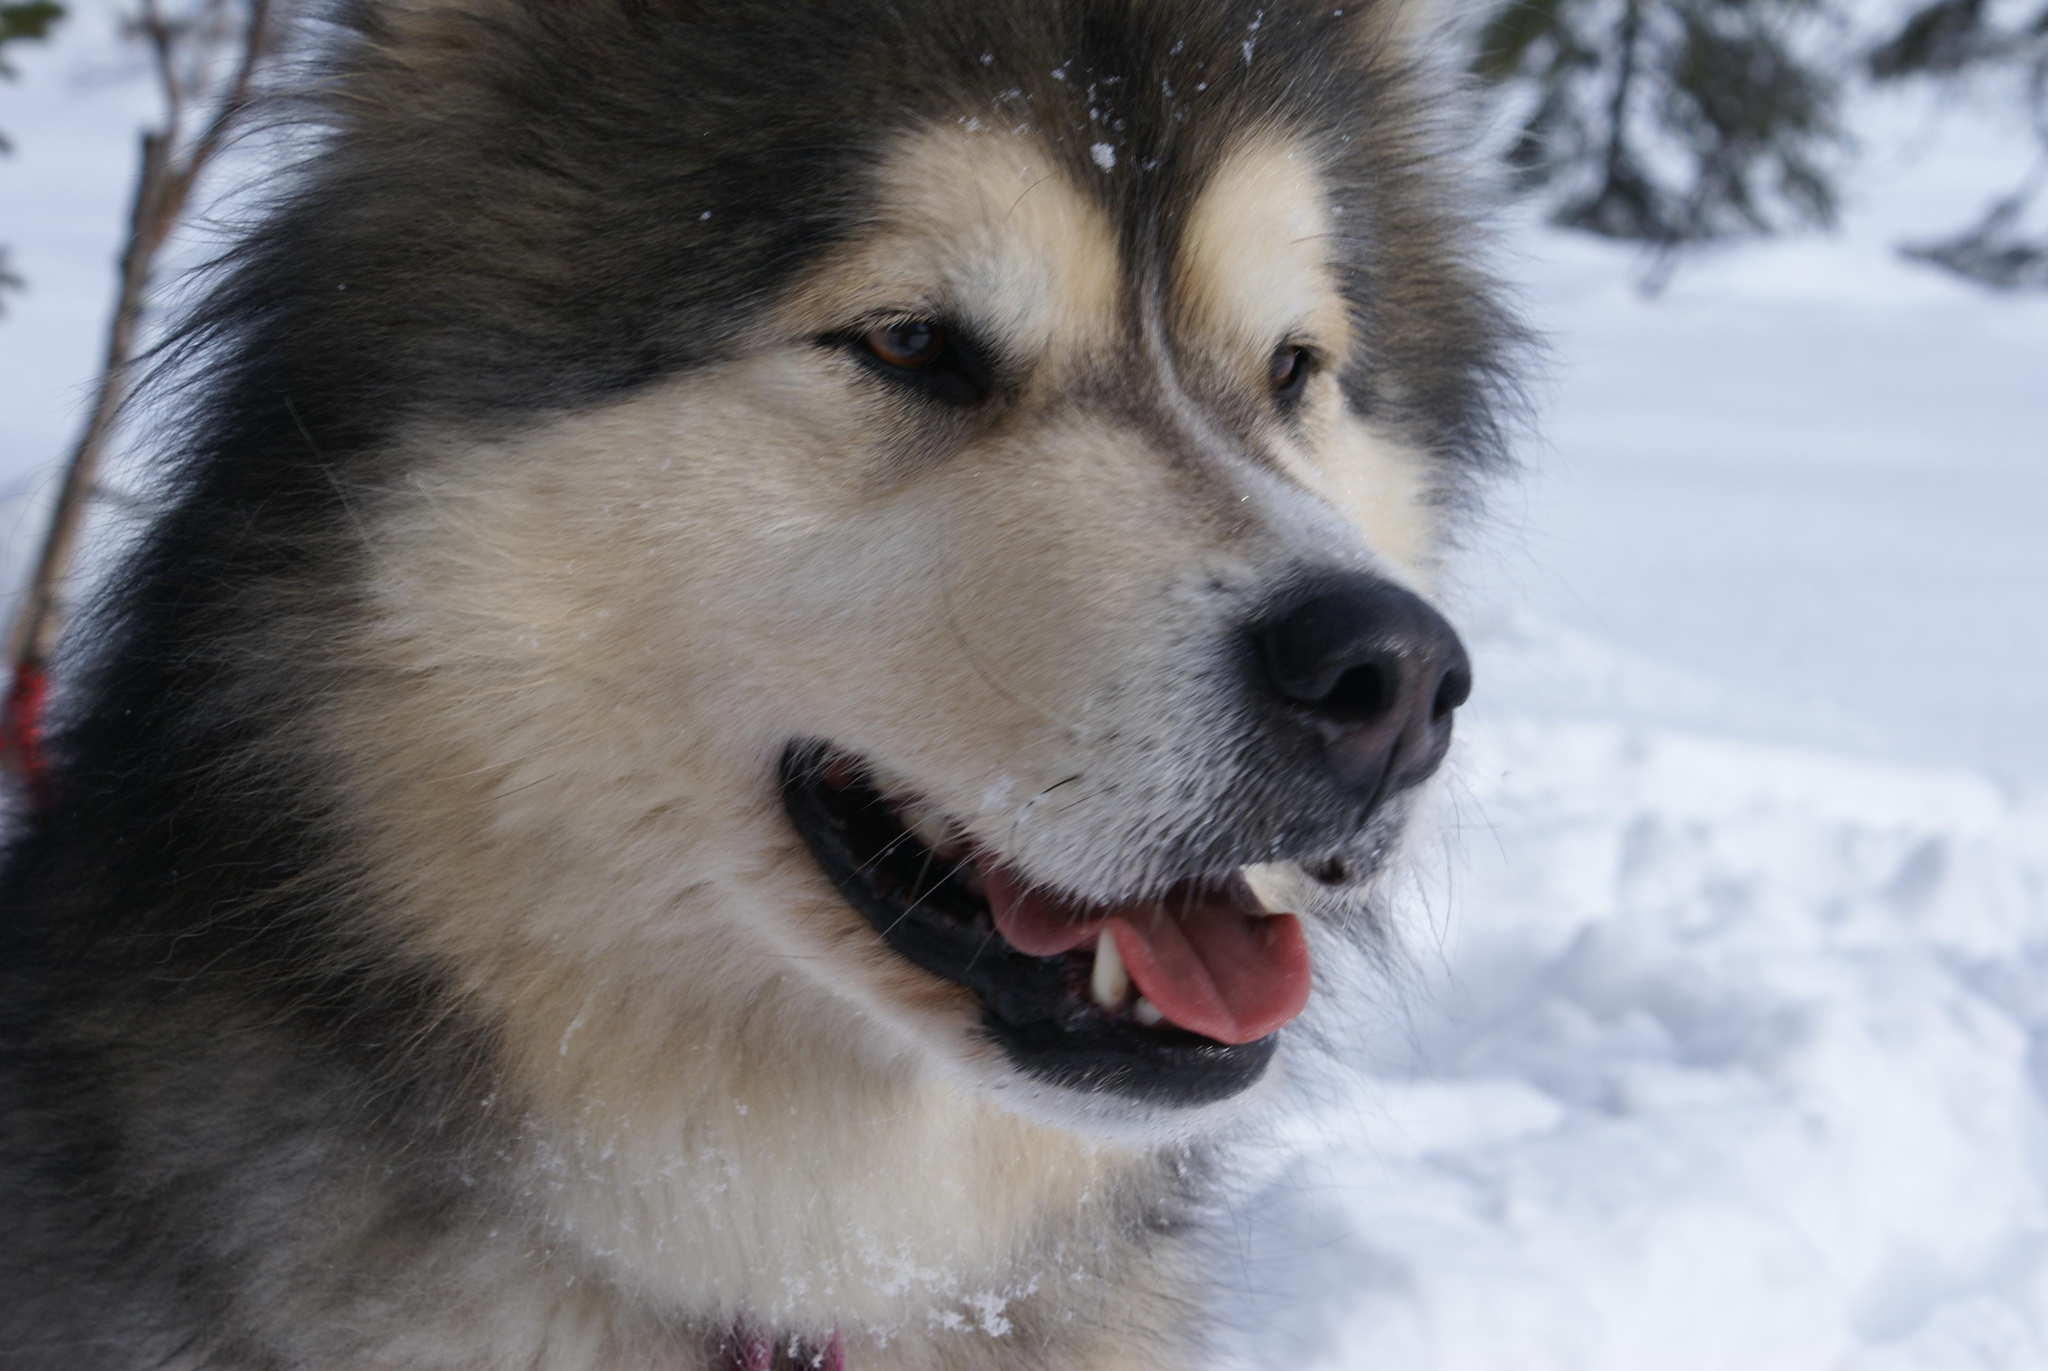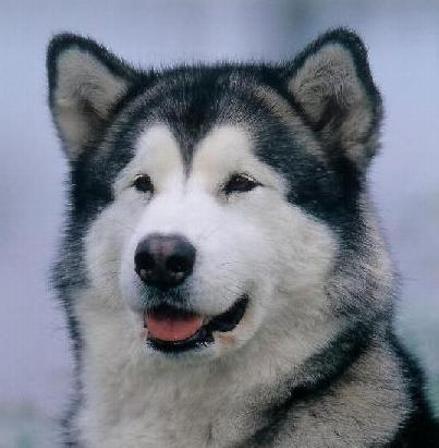The first image is the image on the left, the second image is the image on the right. Examine the images to the left and right. Is the description "There are exactly two dogs in the snow." accurate? Answer yes or no. Yes. The first image is the image on the left, the second image is the image on the right. Considering the images on both sides, is "Each image contains one husky dog, but only one of the images features a dog with its tongue hanging out." valid? Answer yes or no. No. 